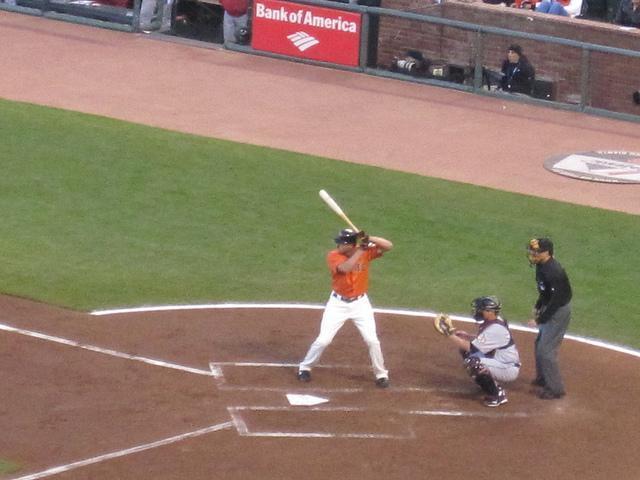How many people can you see?
Give a very brief answer. 3. 